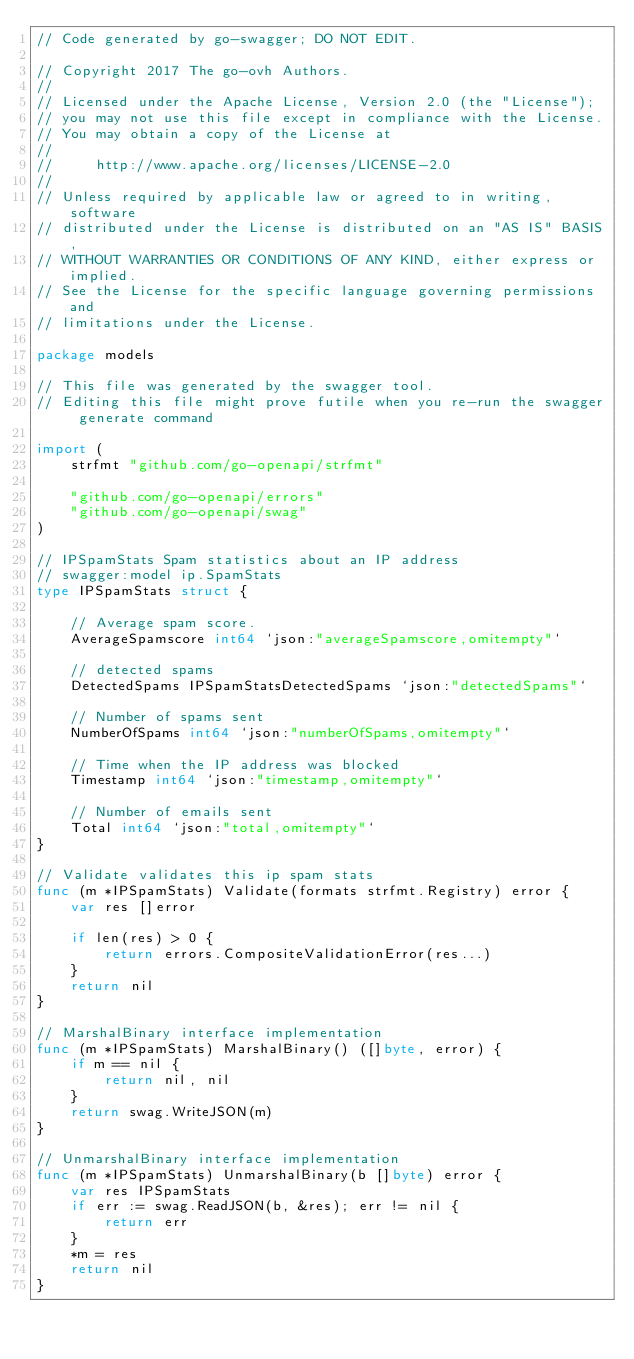Convert code to text. <code><loc_0><loc_0><loc_500><loc_500><_Go_>// Code generated by go-swagger; DO NOT EDIT.

// Copyright 2017 The go-ovh Authors.
//
// Licensed under the Apache License, Version 2.0 (the "License");
// you may not use this file except in compliance with the License.
// You may obtain a copy of the License at
//
//     http://www.apache.org/licenses/LICENSE-2.0
//
// Unless required by applicable law or agreed to in writing, software
// distributed under the License is distributed on an "AS IS" BASIS,
// WITHOUT WARRANTIES OR CONDITIONS OF ANY KIND, either express or implied.
// See the License for the specific language governing permissions and
// limitations under the License.

package models

// This file was generated by the swagger tool.
// Editing this file might prove futile when you re-run the swagger generate command

import (
	strfmt "github.com/go-openapi/strfmt"

	"github.com/go-openapi/errors"
	"github.com/go-openapi/swag"
)

// IPSpamStats Spam statistics about an IP address
// swagger:model ip.SpamStats
type IPSpamStats struct {

	// Average spam score.
	AverageSpamscore int64 `json:"averageSpamscore,omitempty"`

	// detected spams
	DetectedSpams IPSpamStatsDetectedSpams `json:"detectedSpams"`

	// Number of spams sent
	NumberOfSpams int64 `json:"numberOfSpams,omitempty"`

	// Time when the IP address was blocked
	Timestamp int64 `json:"timestamp,omitempty"`

	// Number of emails sent
	Total int64 `json:"total,omitempty"`
}

// Validate validates this ip spam stats
func (m *IPSpamStats) Validate(formats strfmt.Registry) error {
	var res []error

	if len(res) > 0 {
		return errors.CompositeValidationError(res...)
	}
	return nil
}

// MarshalBinary interface implementation
func (m *IPSpamStats) MarshalBinary() ([]byte, error) {
	if m == nil {
		return nil, nil
	}
	return swag.WriteJSON(m)
}

// UnmarshalBinary interface implementation
func (m *IPSpamStats) UnmarshalBinary(b []byte) error {
	var res IPSpamStats
	if err := swag.ReadJSON(b, &res); err != nil {
		return err
	}
	*m = res
	return nil
}
</code> 